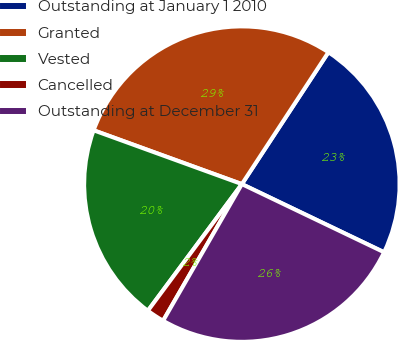<chart> <loc_0><loc_0><loc_500><loc_500><pie_chart><fcel>Outstanding at January 1 2010<fcel>Granted<fcel>Vested<fcel>Cancelled<fcel>Outstanding at December 31<nl><fcel>22.87%<fcel>28.7%<fcel>20.38%<fcel>1.84%<fcel>26.21%<nl></chart> 